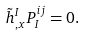Convert formula to latex. <formula><loc_0><loc_0><loc_500><loc_500>\tilde { h } ^ { I } _ { , x } P _ { I } ^ { i j } = 0 .</formula> 